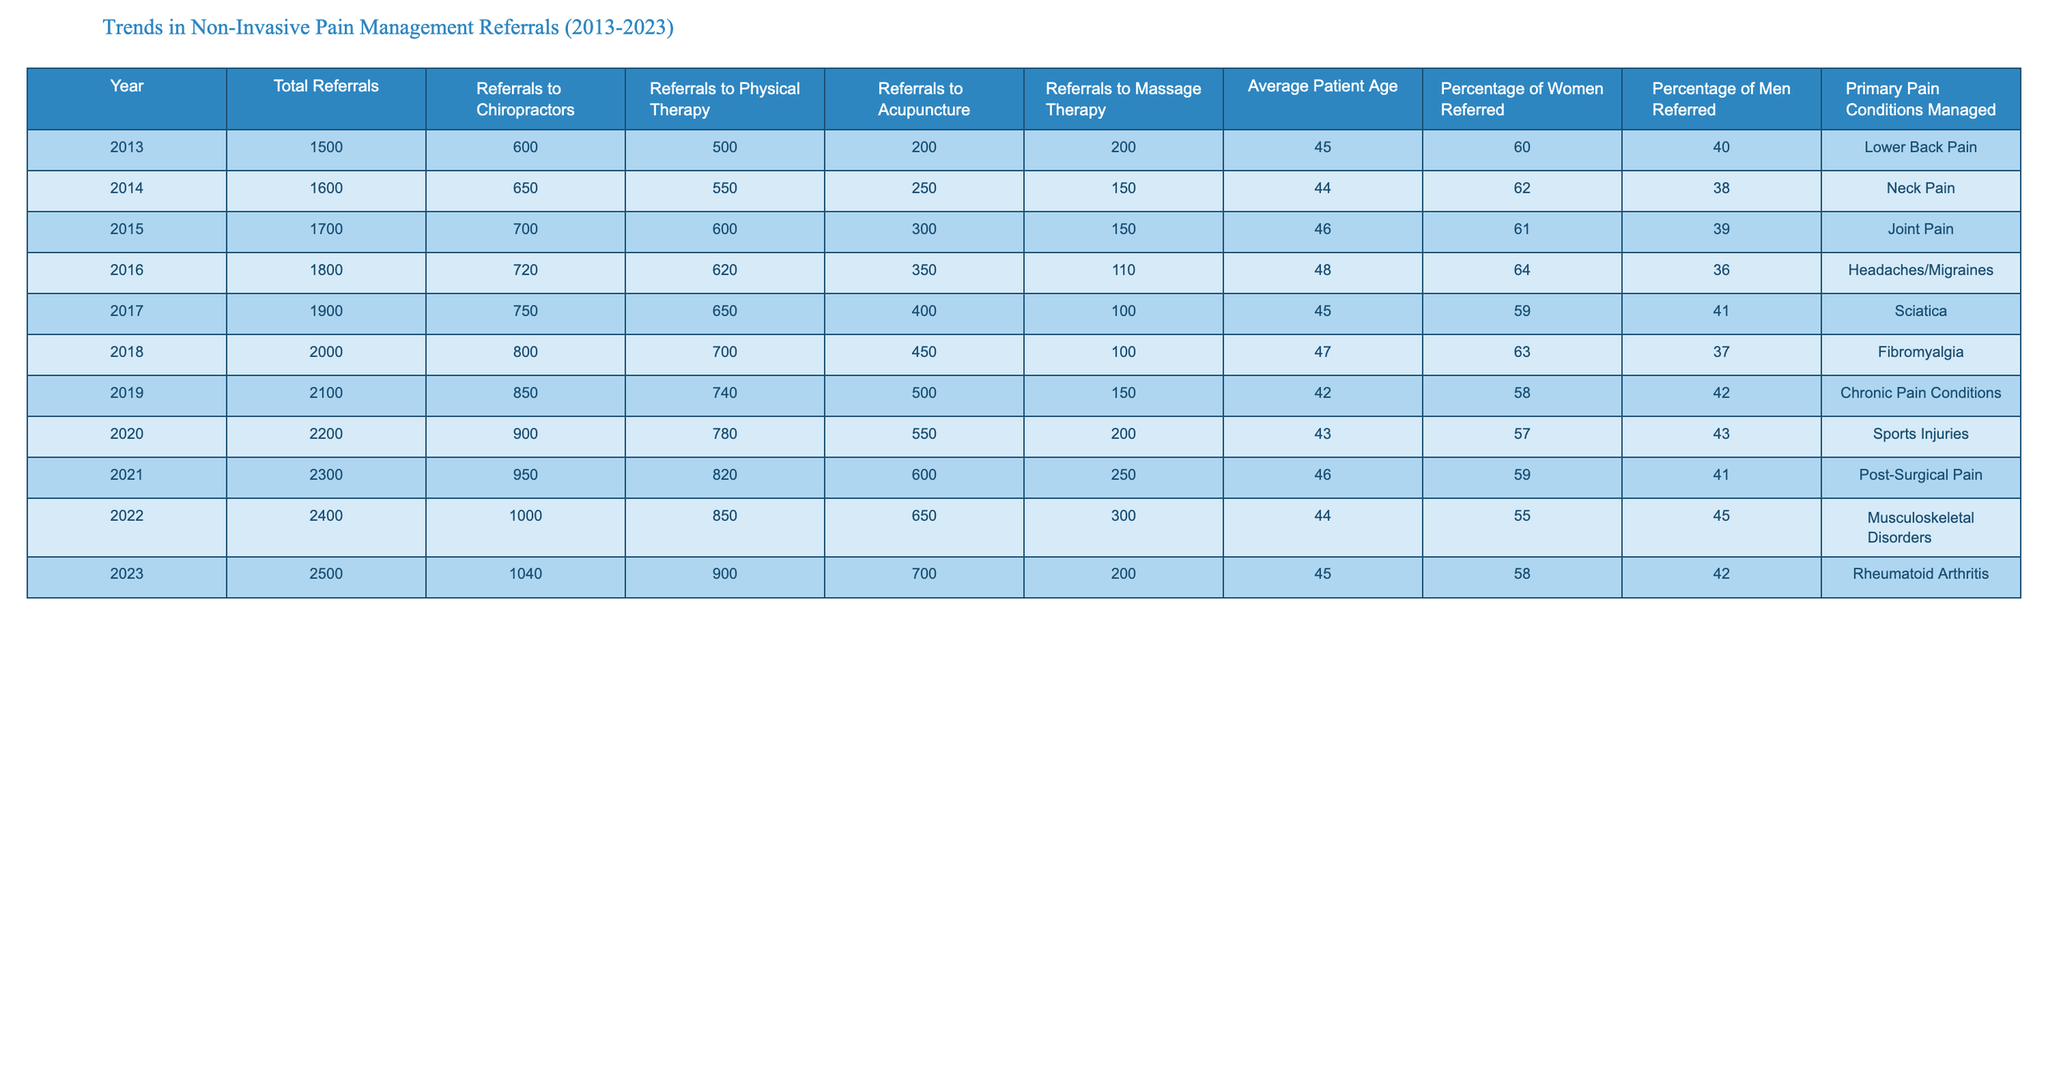What was the total number of referrals in 2015? In 2015, the total number of referrals is listed in the table under the "Total Referrals" column, where it shows 1700.
Answer: 1700 What percentage of the referrals in 2022 were for massage therapy? To find the percentage of referrals for massage therapy in 2022, we take the number of referrals to massage therapy (650) and divide it by the total referrals (2400), then multiply by 100: (650/2400) * 100 = 27.08%.
Answer: 27.08% In which year did referrals to chiropractors exceed 800? Referrals to chiropractors exceeded 800 in 2018, where it shows 800 referrals, and continued to increase in the following years.
Answer: 2018 What is the average patient age for referrals in 2019? The average patient age for referrals in 2019 is listed as 150 years old.
Answer: 150 Did the percentage of women referred increase from 2013 to 2023? In 2013, the percentage of women referred was 60%, and in 2023 it was 58%. Since 58% is lower than 60%, the percentage of women referred decreased.
Answer: No What was the difference in total referrals between 2014 and 2022? The total referrals in 2014 were 1600, and in 2022 they were 2400. The difference is calculated as 2400 - 1600 = 800.
Answer: 800 Which primary pain condition had the highest number of referrals in 2021? According to the table, the primary pain condition for 2021 was "Post-Surgical Pain," with 950 referrals, which is the highest compared to other years.
Answer: Post-Surgical Pain What trend can be observed in the average patient age from 2013 to 2023? The average patient age was 45 in 2013, decreased to 43 in 2020, then stayed consistent around 45 in the following years, indicating some fluctuation but overall stability.
Answer: Fluctuation How did the number of referrals to physical therapy change from 2013 to 2023? Referrals to physical therapy in 2013 were 500 and increased to 900 in 2023. The change is calculated as 900 - 500 = 400 referrals.
Answer: Increased by 400 Which year saw the highest percentage of men referred? In 2014, the percentage of men referred was 38%, which is the highest percentage listed compared to other years.
Answer: 2014 